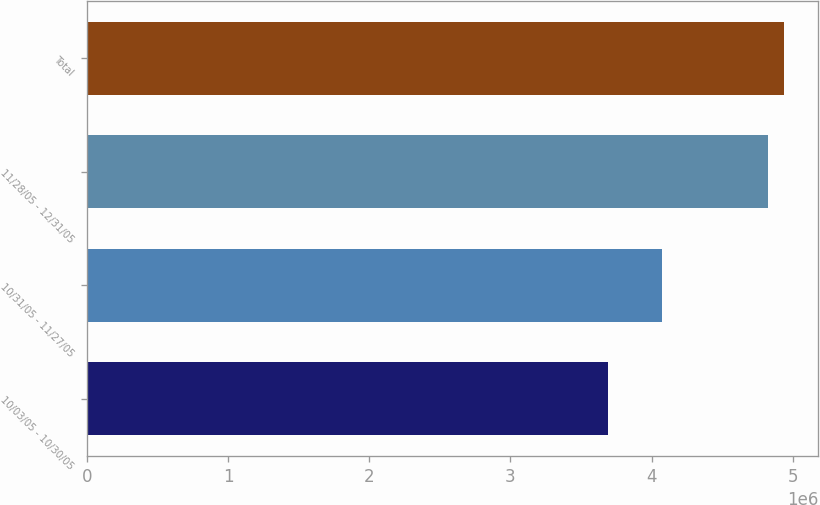<chart> <loc_0><loc_0><loc_500><loc_500><bar_chart><fcel>10/03/05 - 10/30/05<fcel>10/31/05 - 11/27/05<fcel>11/28/05 - 12/31/05<fcel>Total<nl><fcel>3.6901e+06<fcel>4.0726e+06<fcel>4.8231e+06<fcel>4.9364e+06<nl></chart> 